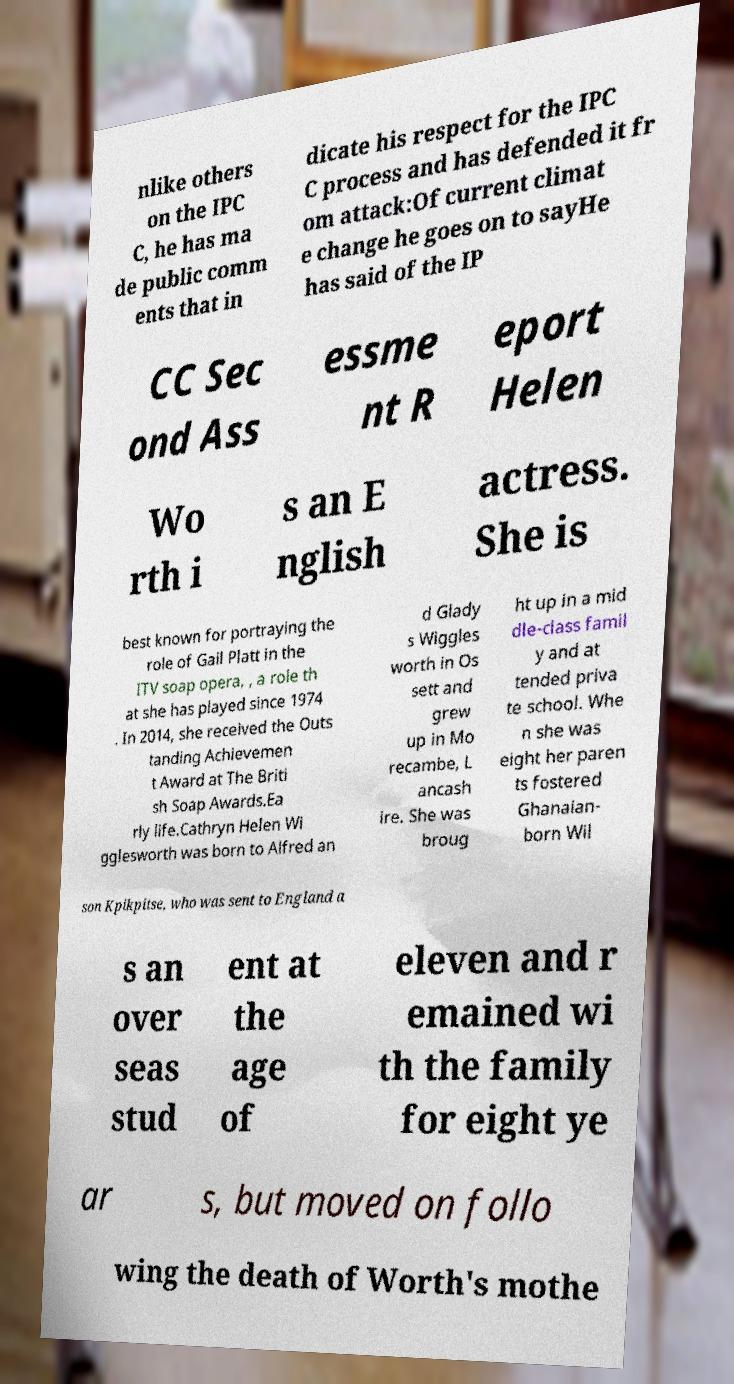I need the written content from this picture converted into text. Can you do that? nlike others on the IPC C, he has ma de public comm ents that in dicate his respect for the IPC C process and has defended it fr om attack:Of current climat e change he goes on to sayHe has said of the IP CC Sec ond Ass essme nt R eport Helen Wo rth i s an E nglish actress. She is best known for portraying the role of Gail Platt in the ITV soap opera, , a role th at she has played since 1974 . In 2014, she received the Outs tanding Achievemen t Award at The Briti sh Soap Awards.Ea rly life.Cathryn Helen Wi gglesworth was born to Alfred an d Glady s Wiggles worth in Os sett and grew up in Mo recambe, L ancash ire. She was broug ht up in a mid dle-class famil y and at tended priva te school. Whe n she was eight her paren ts fostered Ghanaian- born Wil son Kpikpitse, who was sent to England a s an over seas stud ent at the age of eleven and r emained wi th the family for eight ye ar s, but moved on follo wing the death of Worth's mothe 